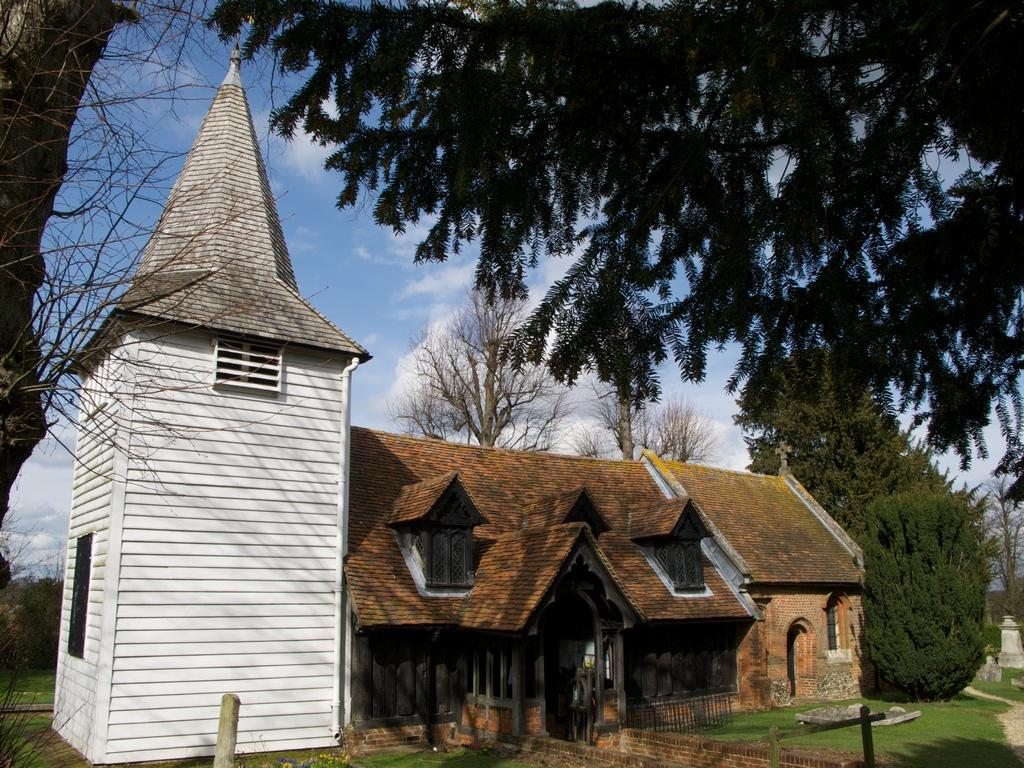What is located in the foreground of the image? There are trees in the foreground of the image. Where are the trees situated in relation to the image? The trees are on the top and on the left side of the image. What can be seen in the background of the image? There is a building, grass, a railing, additional trees, and the sky visible in the background of the image. Can you describe the sky in the image? The sky is visible in the background of the image, and there is a cloud present. What type of feeling can be seen on the faces of the army soldiers in the image? There are no army soldiers or faces present in the image; it features trees, a building, grass, a railing, and the sky. 